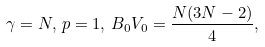<formula> <loc_0><loc_0><loc_500><loc_500>\gamma = N , \, p = 1 , \, B _ { 0 } V _ { 0 } = \frac { N ( 3 N - 2 ) } { 4 } ,</formula> 